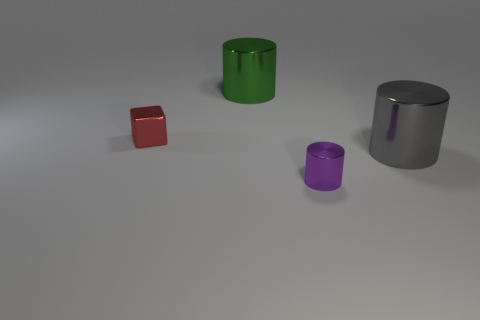Subtract all large shiny cylinders. How many cylinders are left? 1 Subtract all gray cylinders. How many cylinders are left? 2 Add 4 red cubes. How many objects exist? 8 Subtract 0 purple spheres. How many objects are left? 4 Subtract all blocks. How many objects are left? 3 Subtract 1 blocks. How many blocks are left? 0 Subtract all cyan cylinders. Subtract all brown balls. How many cylinders are left? 3 Subtract all purple balls. How many brown cylinders are left? 0 Subtract all cyan rubber spheres. Subtract all large objects. How many objects are left? 2 Add 4 metal cubes. How many metal cubes are left? 5 